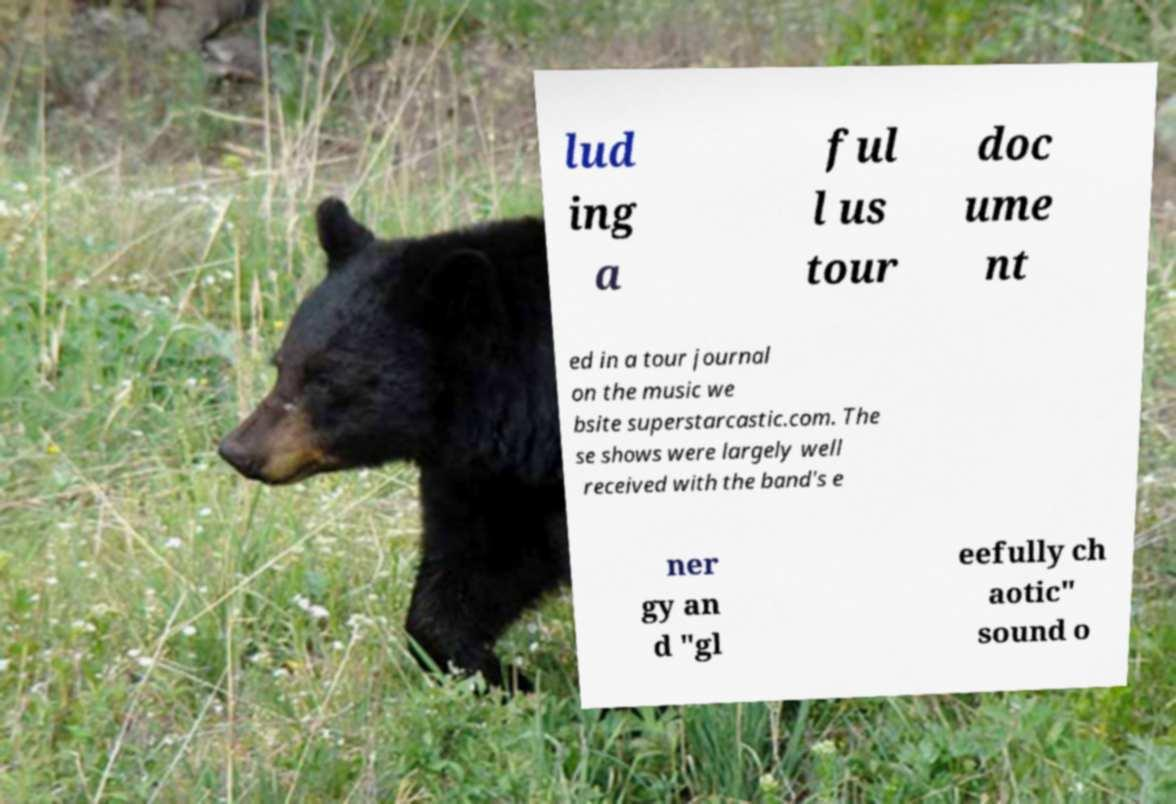Can you accurately transcribe the text from the provided image for me? lud ing a ful l us tour doc ume nt ed in a tour journal on the music we bsite superstarcastic.com. The se shows were largely well received with the band's e ner gy an d "gl eefully ch aotic" sound o 